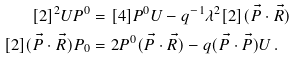<formula> <loc_0><loc_0><loc_500><loc_500>[ 2 ] ^ { 2 } U P ^ { 0 } & = [ 4 ] P ^ { 0 } U - q ^ { - 1 } \lambda ^ { 2 } [ 2 ] ( \vec { P } \cdot \vec { R } ) \\ [ 2 ] ( \vec { P } \cdot \vec { R } ) P _ { 0 } & = 2 P ^ { 0 } ( \vec { P } \cdot \vec { R } ) - q ( \vec { P } \cdot \vec { P } ) U \, .</formula> 